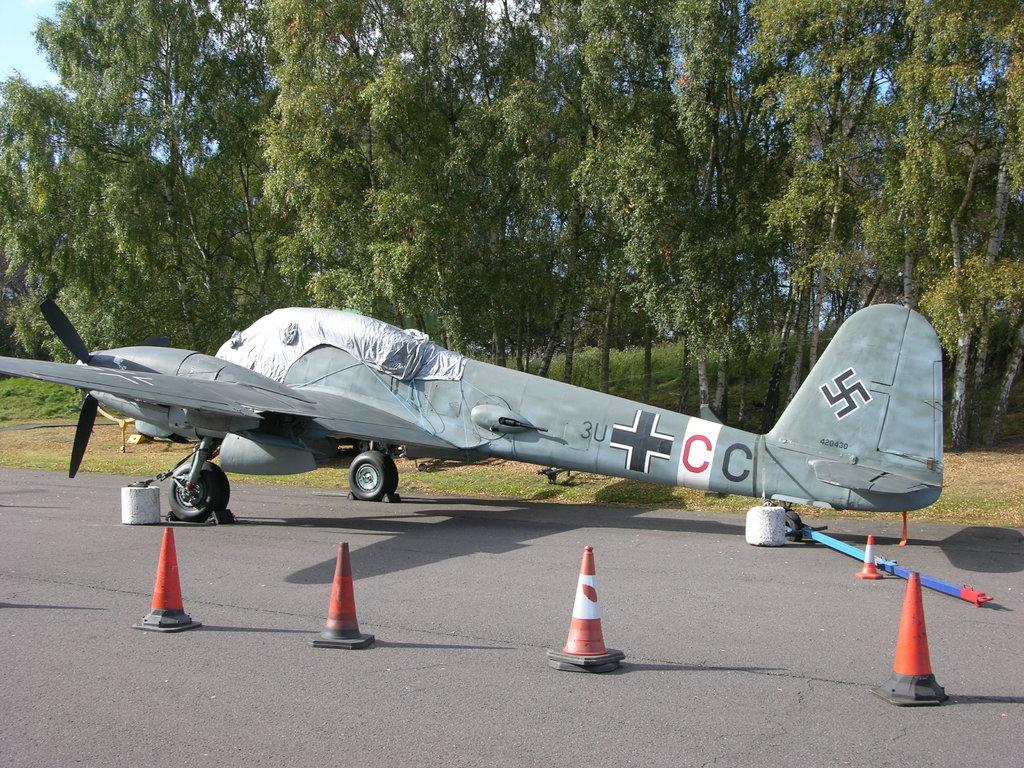What is the main subject of the image? The main subject of the image is an airplane. What color is the airplane? The airplane is grey in color. Where is the airplane located in the image? The airplane is on a runway. What can be seen on the road near the airplane? There are traffic stoppers on the road. What is visible in the background of the image? There are many trees in the background of the image. What type of behavior can be observed in the lizards in the image? There are no lizards present in the image, so no behavior can be observed. What color is the orange in the image? There is no orange present in the image. 